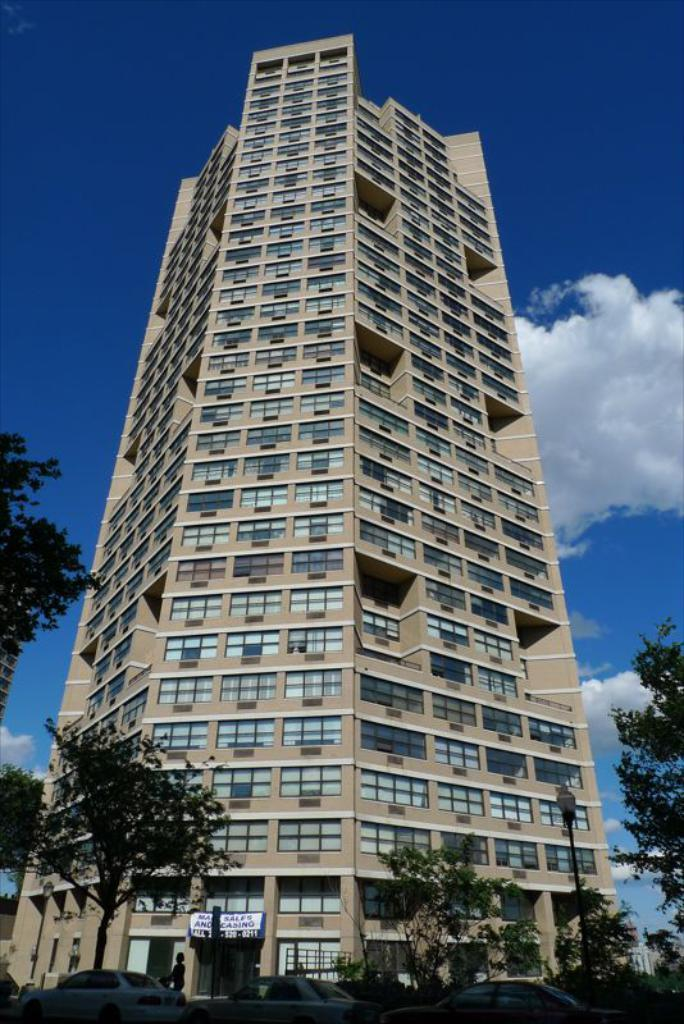What type of building is in the image? There is a skyscraper in the image. What is located at the bottom of the image? There are cars at the bottom of the image. What object can be seen near the cars? There is a street light pole in the image. What is the person in the image doing? There is a person walking in the image. What type of vegetation is present in the image? There are trees in the image. What part of the natural environment is visible in the image? The sky is visible behind the skyscraper. Where is the cherry tree located in the image? There is no cherry tree present in the image. What animals can be seen at the zoo in the image? There is no zoo present in the image. 